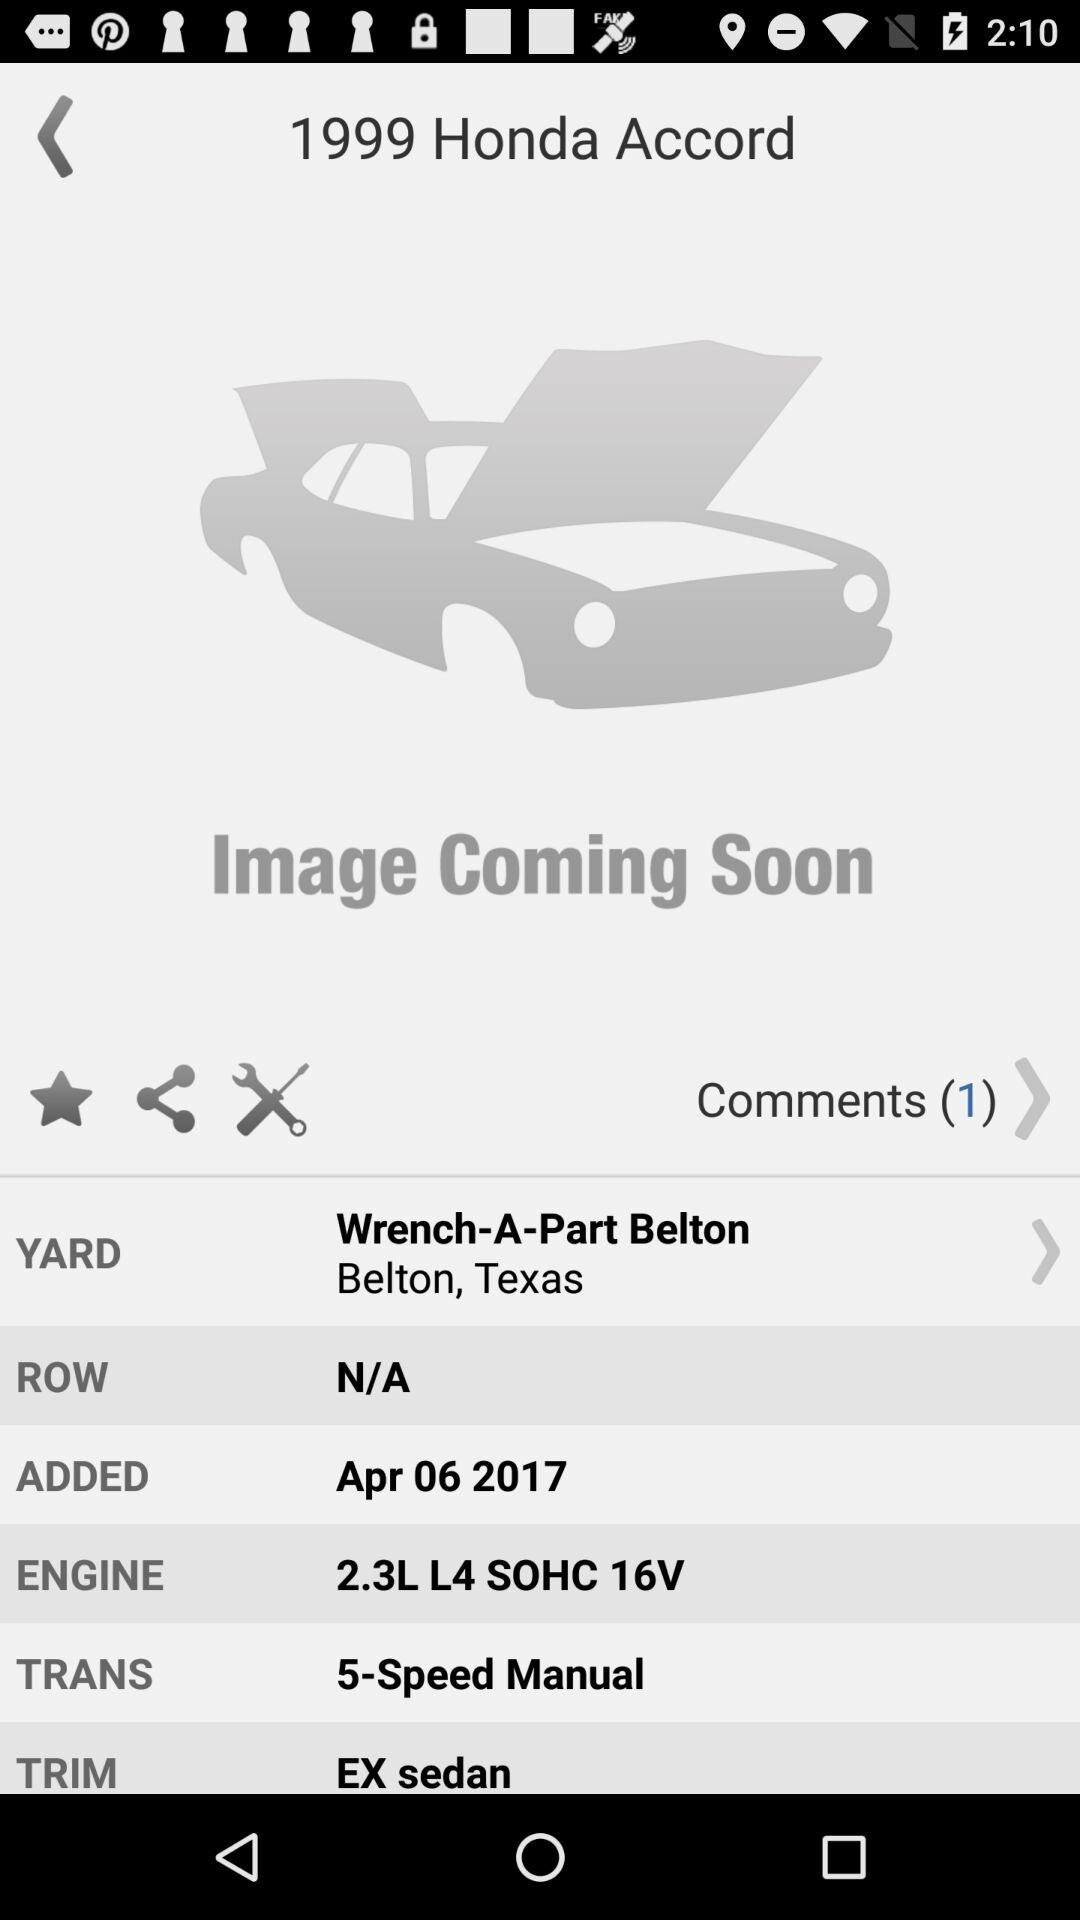When was the comment made?
When the provided information is insufficient, respond with <no answer>. <no answer> 